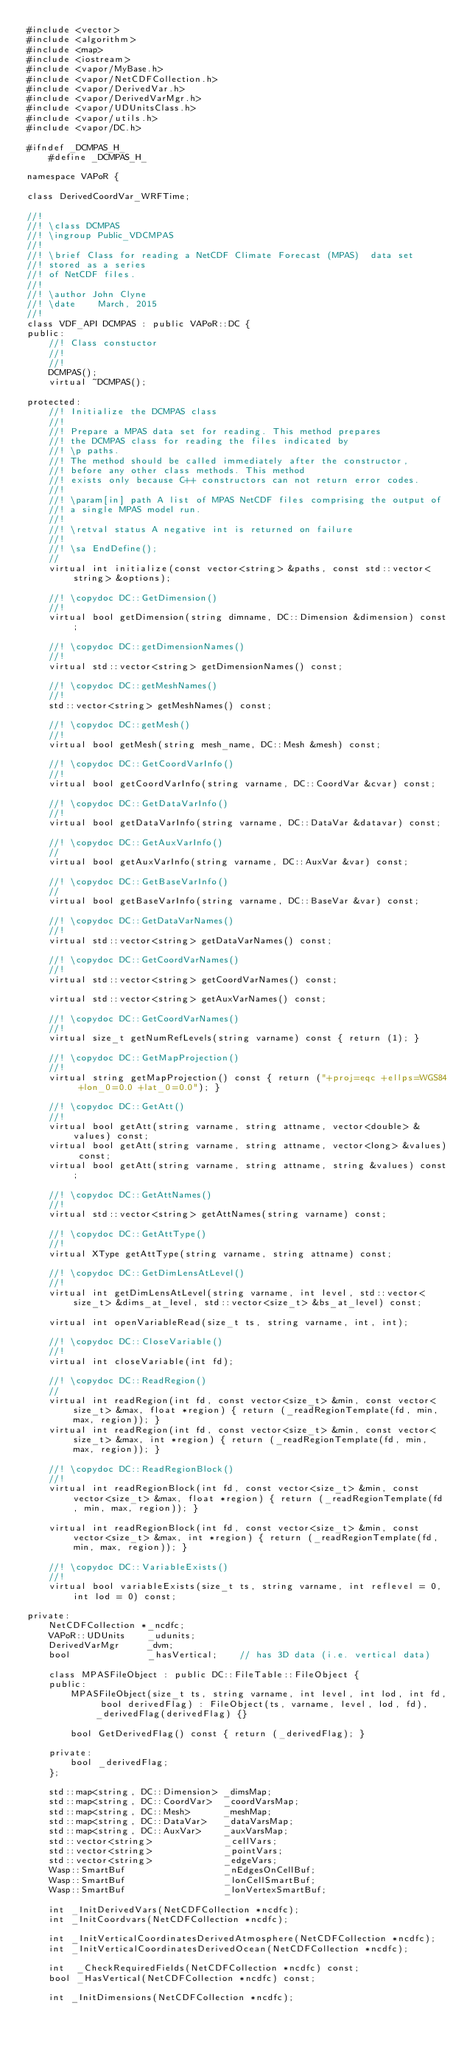<code> <loc_0><loc_0><loc_500><loc_500><_C_>#include <vector>
#include <algorithm>
#include <map>
#include <iostream>
#include <vapor/MyBase.h>
#include <vapor/NetCDFCollection.h>
#include <vapor/DerivedVar.h>
#include <vapor/DerivedVarMgr.h>
#include <vapor/UDUnitsClass.h>
#include <vapor/utils.h>
#include <vapor/DC.h>

#ifndef _DCMPAS_H_
    #define _DCMPAS_H_

namespace VAPoR {

class DerivedCoordVar_WRFTime;

//!
//! \class DCMPAS
//! \ingroup Public_VDCMPAS
//!
//! \brief Class for reading a NetCDF Climate Forecast (MPAS)  data set
//! stored as a series
//! of NetCDF files.
//!
//! \author John Clyne
//! \date    March, 2015
//!
class VDF_API DCMPAS : public VAPoR::DC {
public:
    //! Class constuctor
    //!
    //!
    DCMPAS();
    virtual ~DCMPAS();

protected:
    //! Initialize the DCMPAS class
    //!
    //! Prepare a MPAS data set for reading. This method prepares
    //! the DCMPAS class for reading the files indicated by
    //! \p paths.
    //! The method should be called immediately after the constructor,
    //! before any other class methods. This method
    //! exists only because C++ constructors can not return error codes.
    //!
    //! \param[in] path A list of MPAS NetCDF files comprising the output of
    //! a single MPAS model run.
    //!
    //! \retval status A negative int is returned on failure
    //!
    //! \sa EndDefine();
    //
    virtual int initialize(const vector<string> &paths, const std::vector<string> &options);

    //! \copydoc DC::GetDimension()
    //!
    virtual bool getDimension(string dimname, DC::Dimension &dimension) const;

    //! \copydoc DC::getDimensionNames()
    //!
    virtual std::vector<string> getDimensionNames() const;

    //! \copydoc DC::getMeshNames()
    //!
    std::vector<string> getMeshNames() const;

    //! \copydoc DC::getMesh()
    //!
    virtual bool getMesh(string mesh_name, DC::Mesh &mesh) const;

    //! \copydoc DC::GetCoordVarInfo()
    //!
    virtual bool getCoordVarInfo(string varname, DC::CoordVar &cvar) const;

    //! \copydoc DC::GetDataVarInfo()
    //!
    virtual bool getDataVarInfo(string varname, DC::DataVar &datavar) const;

    //! \copydoc DC::GetAuxVarInfo()
    //
    virtual bool getAuxVarInfo(string varname, DC::AuxVar &var) const;

    //! \copydoc DC::GetBaseVarInfo()
    //
    virtual bool getBaseVarInfo(string varname, DC::BaseVar &var) const;

    //! \copydoc DC::GetDataVarNames()
    //!
    virtual std::vector<string> getDataVarNames() const;

    //! \copydoc DC::GetCoordVarNames()
    //!
    virtual std::vector<string> getCoordVarNames() const;

    virtual std::vector<string> getAuxVarNames() const;

    //! \copydoc DC::GetCoordVarNames()
    //!
    virtual size_t getNumRefLevels(string varname) const { return (1); }

    //! \copydoc DC::GetMapProjection()
    //!
    virtual string getMapProjection() const { return ("+proj=eqc +ellps=WGS84 +lon_0=0.0 +lat_0=0.0"); }

    //! \copydoc DC::GetAtt()
    //!
    virtual bool getAtt(string varname, string attname, vector<double> &values) const;
    virtual bool getAtt(string varname, string attname, vector<long> &values) const;
    virtual bool getAtt(string varname, string attname, string &values) const;

    //! \copydoc DC::GetAttNames()
    //!
    virtual std::vector<string> getAttNames(string varname) const;

    //! \copydoc DC::GetAttType()
    //!
    virtual XType getAttType(string varname, string attname) const;

    //! \copydoc DC::GetDimLensAtLevel()
    //!
    virtual int getDimLensAtLevel(string varname, int level, std::vector<size_t> &dims_at_level, std::vector<size_t> &bs_at_level) const;

    virtual int openVariableRead(size_t ts, string varname, int, int);

    //! \copydoc DC::CloseVariable()
    //!
    virtual int closeVariable(int fd);

    //! \copydoc DC::ReadRegion()
    //
    virtual int readRegion(int fd, const vector<size_t> &min, const vector<size_t> &max, float *region) { return (_readRegionTemplate(fd, min, max, region)); }
    virtual int readRegion(int fd, const vector<size_t> &min, const vector<size_t> &max, int *region) { return (_readRegionTemplate(fd, min, max, region)); }

    //! \copydoc DC::ReadRegionBlock()
    //!
    virtual int readRegionBlock(int fd, const vector<size_t> &min, const vector<size_t> &max, float *region) { return (_readRegionTemplate(fd, min, max, region)); }

    virtual int readRegionBlock(int fd, const vector<size_t> &min, const vector<size_t> &max, int *region) { return (_readRegionTemplate(fd, min, max, region)); }

    //! \copydoc DC::VariableExists()
    //!
    virtual bool variableExists(size_t ts, string varname, int reflevel = 0, int lod = 0) const;

private:
    NetCDFCollection *_ncdfc;
    VAPoR::UDUnits    _udunits;
    DerivedVarMgr     _dvm;
    bool              _hasVertical;    // has 3D data (i.e. vertical data)

    class MPASFileObject : public DC::FileTable::FileObject {
    public:
        MPASFileObject(size_t ts, string varname, int level, int lod, int fd, bool derivedFlag) : FileObject(ts, varname, level, lod, fd), _derivedFlag(derivedFlag) {}

        bool GetDerivedFlag() const { return (_derivedFlag); }

    private:
        bool _derivedFlag;
    };

    std::map<string, DC::Dimension> _dimsMap;
    std::map<string, DC::CoordVar>  _coordVarsMap;
    std::map<string, DC::Mesh>      _meshMap;
    std::map<string, DC::DataVar>   _dataVarsMap;
    std::map<string, DC::AuxVar>    _auxVarsMap;
    std::vector<string>             _cellVars;
    std::vector<string>             _pointVars;
    std::vector<string>             _edgeVars;
    Wasp::SmartBuf                  _nEdgesOnCellBuf;
    Wasp::SmartBuf                  _lonCellSmartBuf;
    Wasp::SmartBuf                  _lonVertexSmartBuf;

    int _InitDerivedVars(NetCDFCollection *ncdfc);
    int _InitCoordvars(NetCDFCollection *ncdfc);

    int _InitVerticalCoordinatesDerivedAtmosphere(NetCDFCollection *ncdfc);
    int _InitVerticalCoordinatesDerivedOcean(NetCDFCollection *ncdfc);

    int  _CheckRequiredFields(NetCDFCollection *ncdfc) const;
    bool _HasVertical(NetCDFCollection *ncdfc) const;

    int _InitDimensions(NetCDFCollection *ncdfc);
</code> 